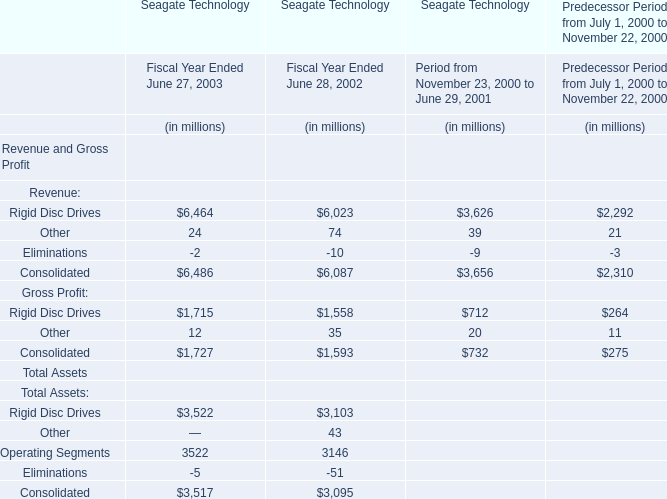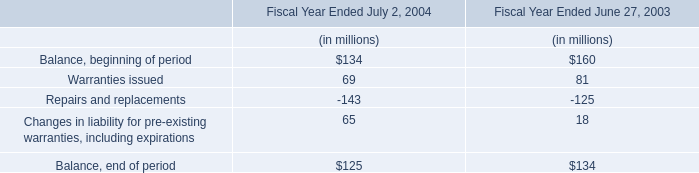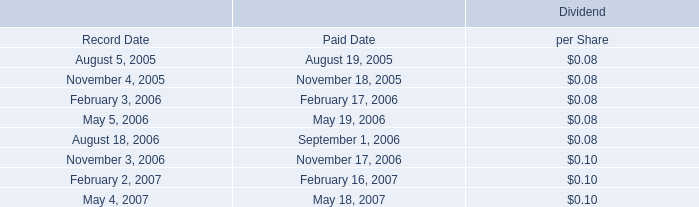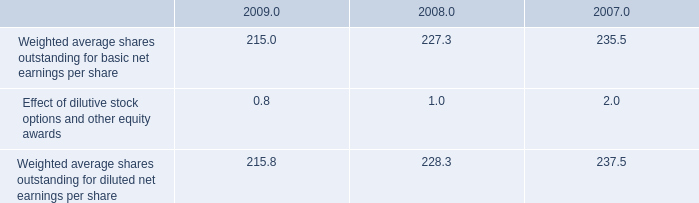What was the average of Consolidated for Revenue and Gross Profit in 2001,2002,and 2003? (in million) 
Computations: (((6486 + 6087) + 3656) / 3)
Answer: 5409.66667. 